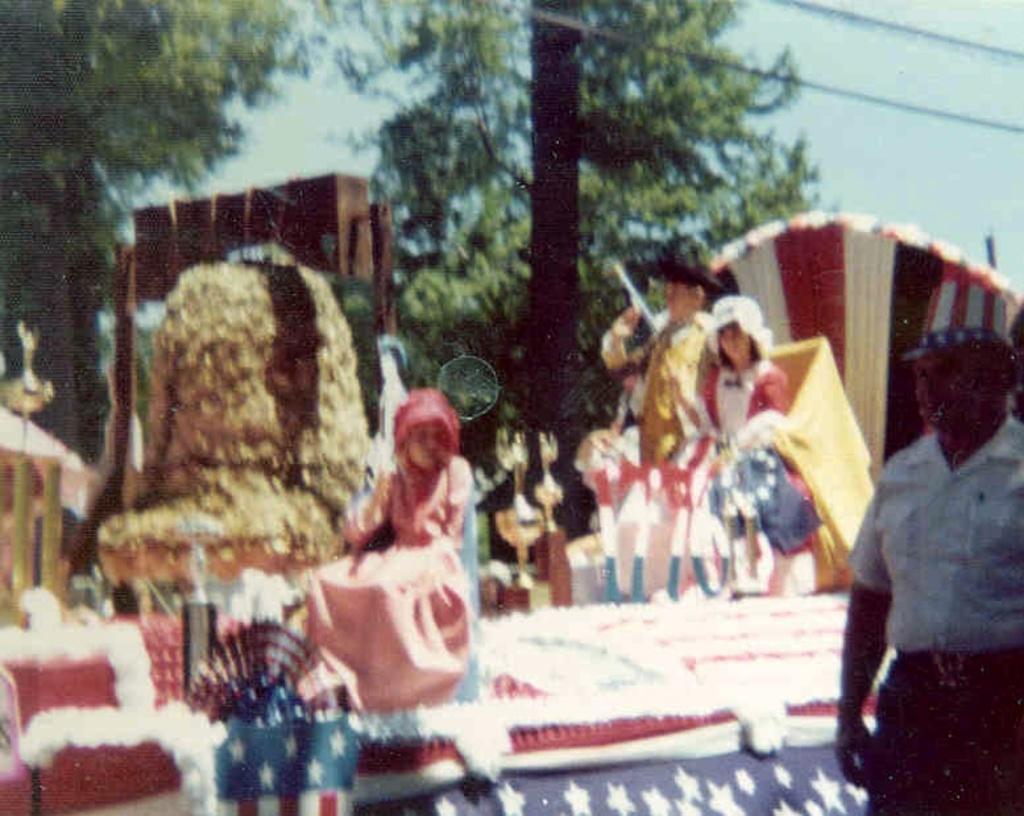Please provide a concise description of this image. In this image there is one person at right side is wearing white color shirt. There is one stage in middle of this image and there is one person sitting in white color dress is at right side of this image and there are some trees in the background and there is a sky at top of this image. there are some objects kept at left side of this image. There is one person standing in middle of this image. 